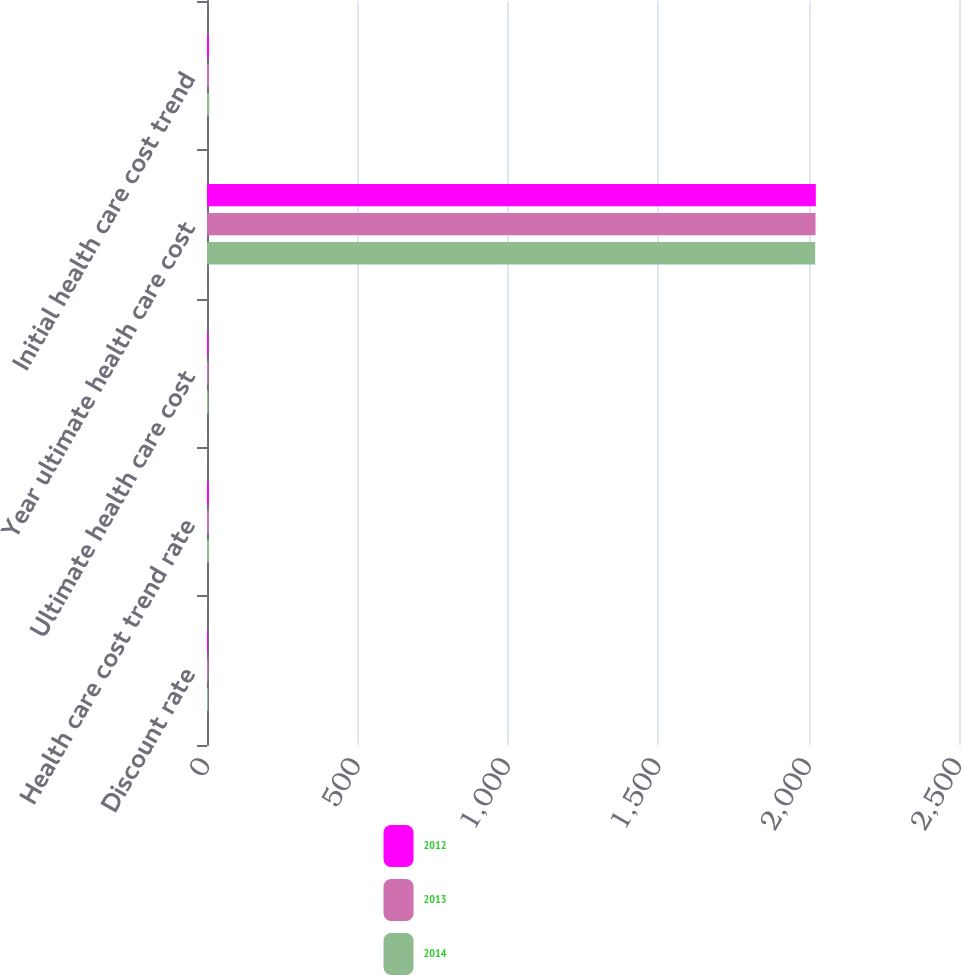Convert chart. <chart><loc_0><loc_0><loc_500><loc_500><stacked_bar_chart><ecel><fcel>Discount rate<fcel>Health care cost trend rate<fcel>Ultimate health care cost<fcel>Year ultimate health care cost<fcel>Initial health care cost trend<nl><fcel>2012<fcel>3.79<fcel>6.31<fcel>4.77<fcel>2024<fcel>6.64<nl><fcel>2013<fcel>4.48<fcel>6.64<fcel>4.77<fcel>2023<fcel>6.96<nl><fcel>2014<fcel>3.79<fcel>6.96<fcel>4.53<fcel>2022<fcel>7.6<nl></chart> 